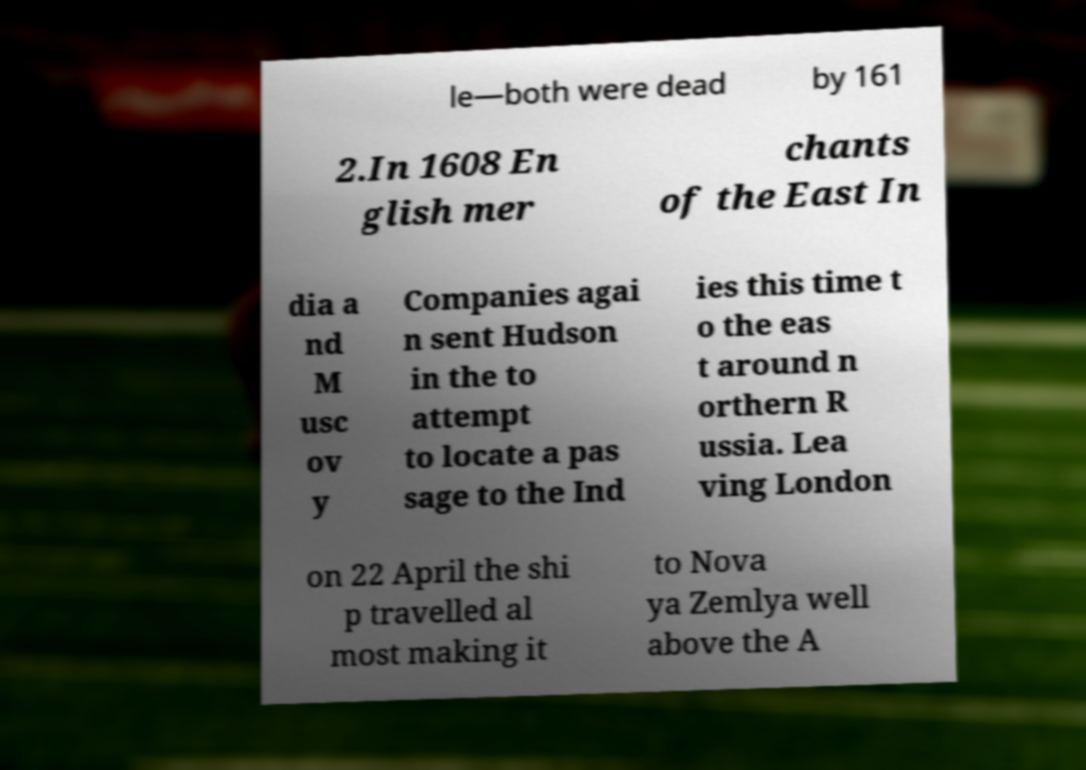What is the historical significance of the events mentioned in this image? The text refers to the attempts by English merchants to find a sea route to the Indies, exemplifying the Age of Discovery when European powers were exploring new trade routes. It particularly mentions Henry Hudson's voyages, which were significant in the exploration of North America and searching for a northern passage to Asia. Hudson's explorations eventually led to the mapping of what became known as Hudson Bay in Canada. 